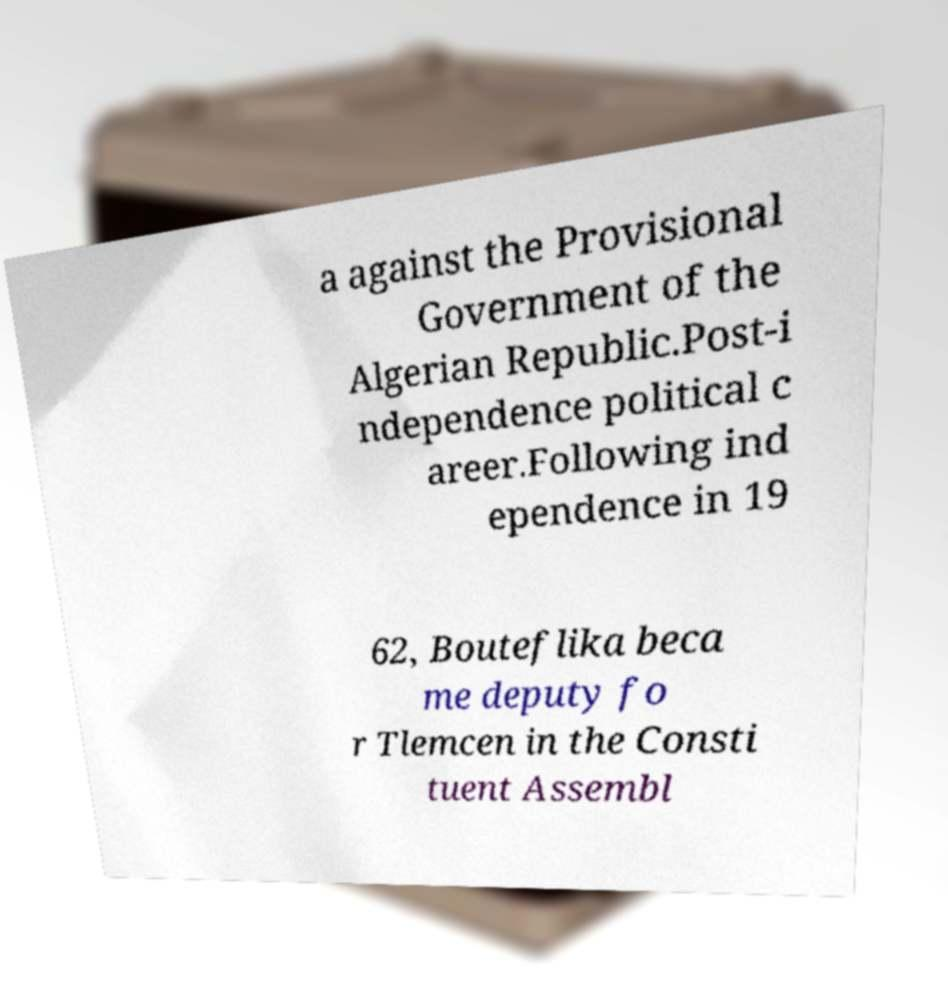Please read and relay the text visible in this image. What does it say? a against the Provisional Government of the Algerian Republic.Post-i ndependence political c areer.Following ind ependence in 19 62, Bouteflika beca me deputy fo r Tlemcen in the Consti tuent Assembl 